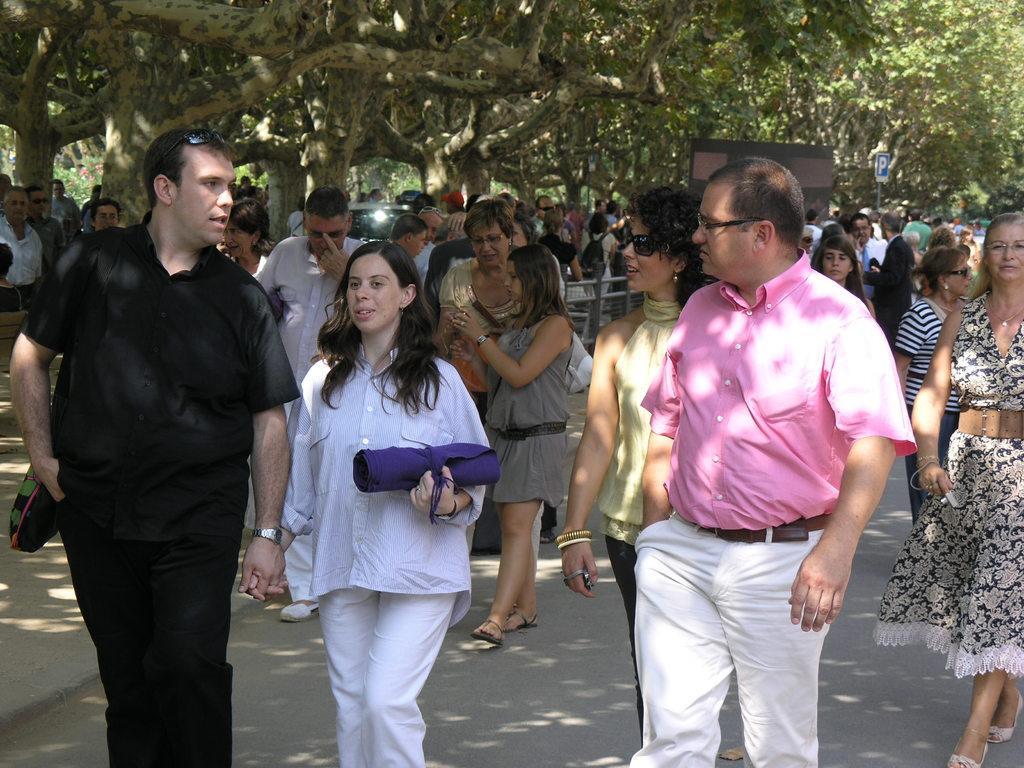How would you summarize this image in a sentence or two? In this picture I can see few people walking and few people are standing and I can see trees and a sign board to the pole and I can see a woman holding a cloth roll in her hand and few of them wore spectacles on their faces. 